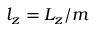Convert formula to latex. <formula><loc_0><loc_0><loc_500><loc_500>l _ { z } = L _ { z } / m</formula> 